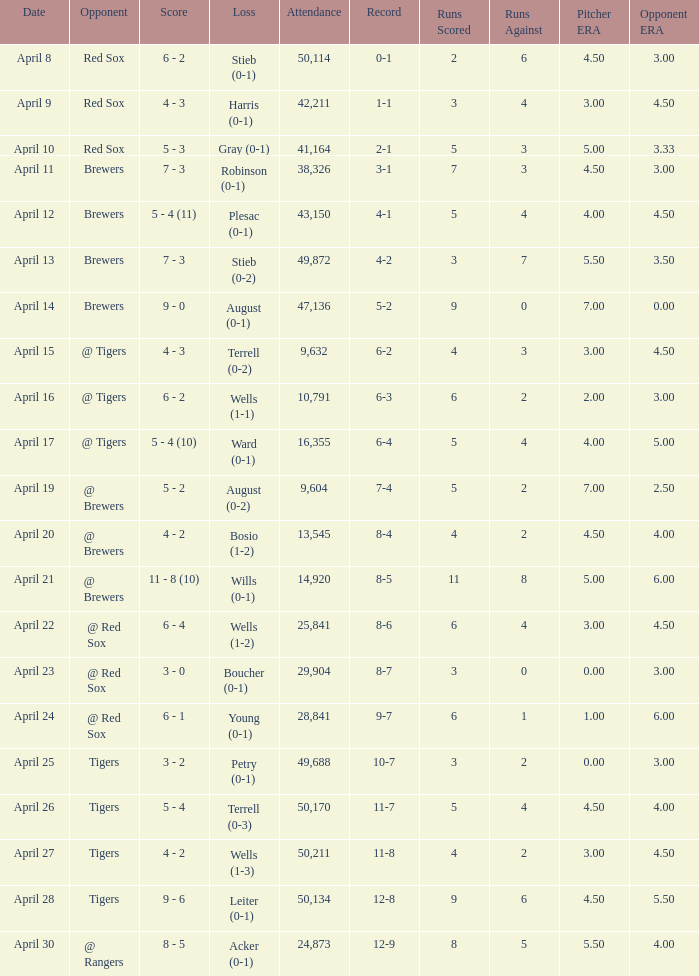Which opponent has an attendance greater than 29,904 and 11-8 as the record? Tigers. 